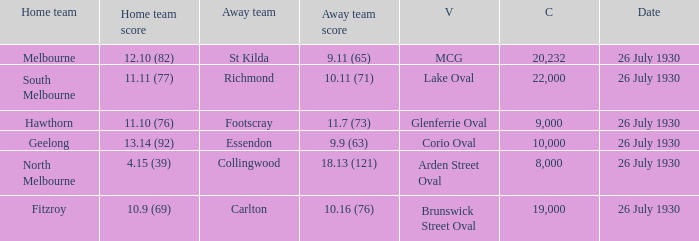Where did Geelong play a home game? Corio Oval. Could you help me parse every detail presented in this table? {'header': ['Home team', 'Home team score', 'Away team', 'Away team score', 'V', 'C', 'Date'], 'rows': [['Melbourne', '12.10 (82)', 'St Kilda', '9.11 (65)', 'MCG', '20,232', '26 July 1930'], ['South Melbourne', '11.11 (77)', 'Richmond', '10.11 (71)', 'Lake Oval', '22,000', '26 July 1930'], ['Hawthorn', '11.10 (76)', 'Footscray', '11.7 (73)', 'Glenferrie Oval', '9,000', '26 July 1930'], ['Geelong', '13.14 (92)', 'Essendon', '9.9 (63)', 'Corio Oval', '10,000', '26 July 1930'], ['North Melbourne', '4.15 (39)', 'Collingwood', '18.13 (121)', 'Arden Street Oval', '8,000', '26 July 1930'], ['Fitzroy', '10.9 (69)', 'Carlton', '10.16 (76)', 'Brunswick Street Oval', '19,000', '26 July 1930']]} 